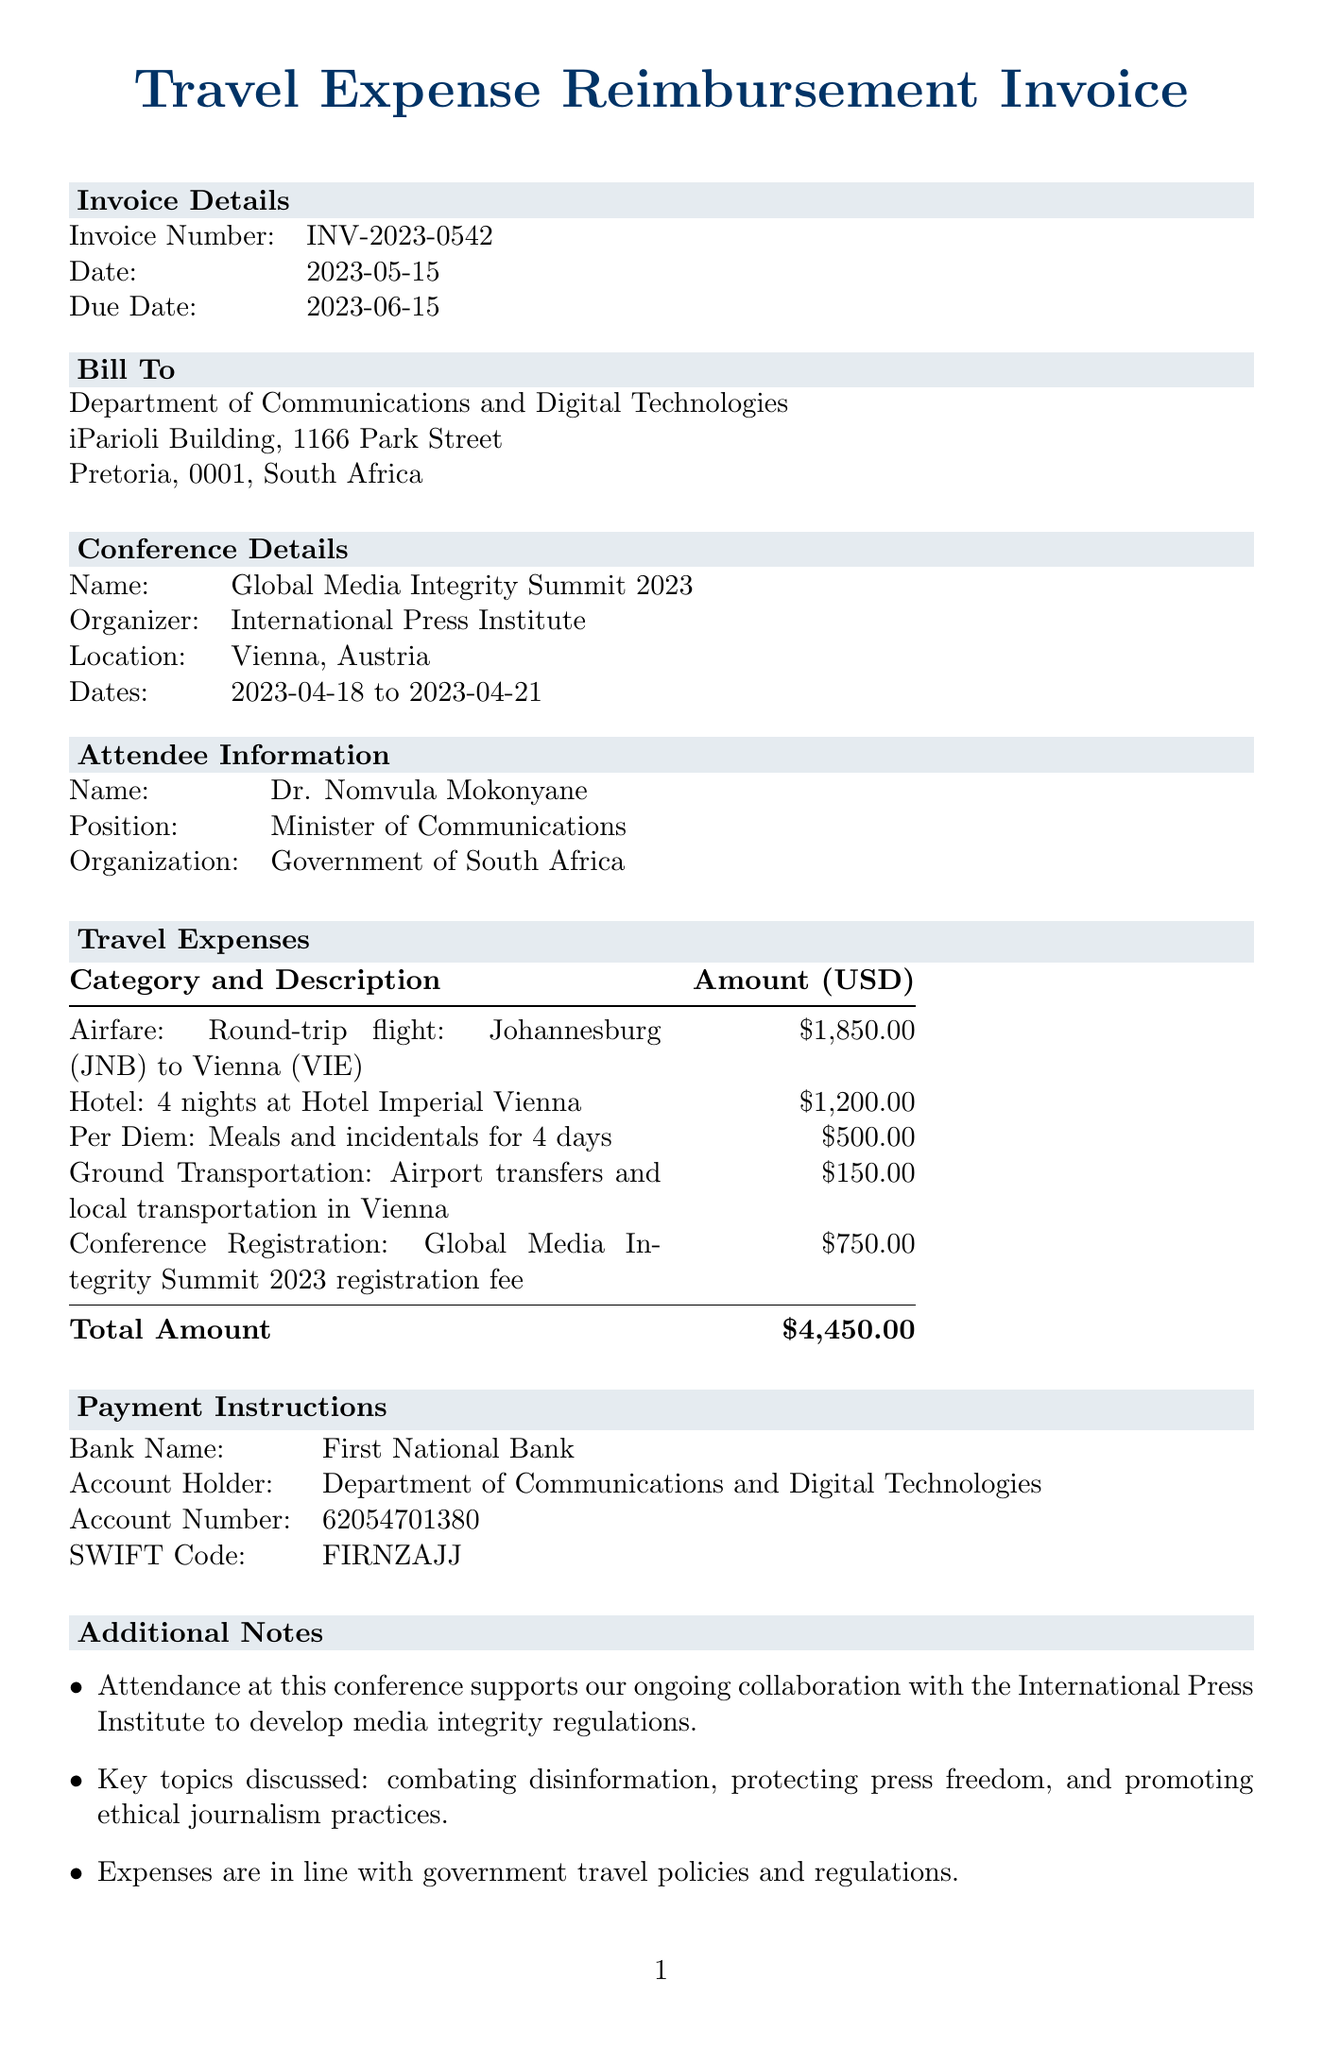What is the invoice number? The invoice number is specifically listed in the document under invoice details.
Answer: INV-2023-0542 What are the conference dates? The conference dates are mentioned in the conference details section of the document.
Answer: 2023-04-18 to 2023-04-21 Who is the attendee? The attendee's name is provided in the attendee information section of the document.
Answer: Dr. Nomvula Mokonyane What is the total amount for reimbursement? The total amount is given at the end of the travel expenses section.
Answer: $4,450.00 How many nights was the hotel booked? The number of nights is specified in the travel expenses under hotel category.
Answer: 4 nights What is the rate for per diem per day? The daily rate for per diem is clearly stated in the per diem description in the travel expenses.
Answer: $125.00 What type of document is this? This document is categorized as an invoice based on its header and content.
Answer: Invoice What organization is hosting the conference? The organizer of the conference is mentioned in the conference details section.
Answer: International Press Institute 